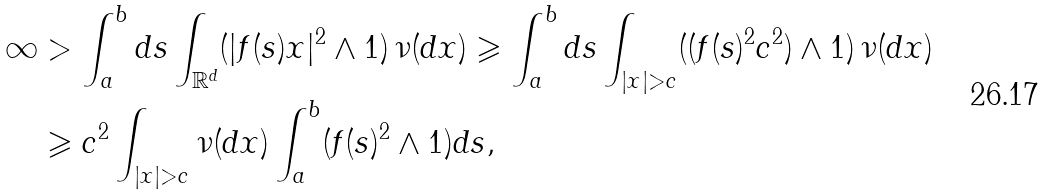Convert formula to latex. <formula><loc_0><loc_0><loc_500><loc_500>\infty & > \int _ { a } ^ { b } d s \int _ { \mathbb { R } ^ { d } } ( | f ( s ) x | ^ { 2 } \land 1 ) \, \nu ( d x ) \geqslant \int _ { a } ^ { b } d s \int _ { | x | > c } ( ( f ( s ) ^ { 2 } c ^ { 2 } ) \land 1 ) \, \nu ( d x ) \\ & \geqslant c ^ { 2 } \int _ { | x | > c } \nu ( d x ) \int _ { a } ^ { b } ( f ( s ) ^ { 2 } \land 1 ) d s ,</formula> 